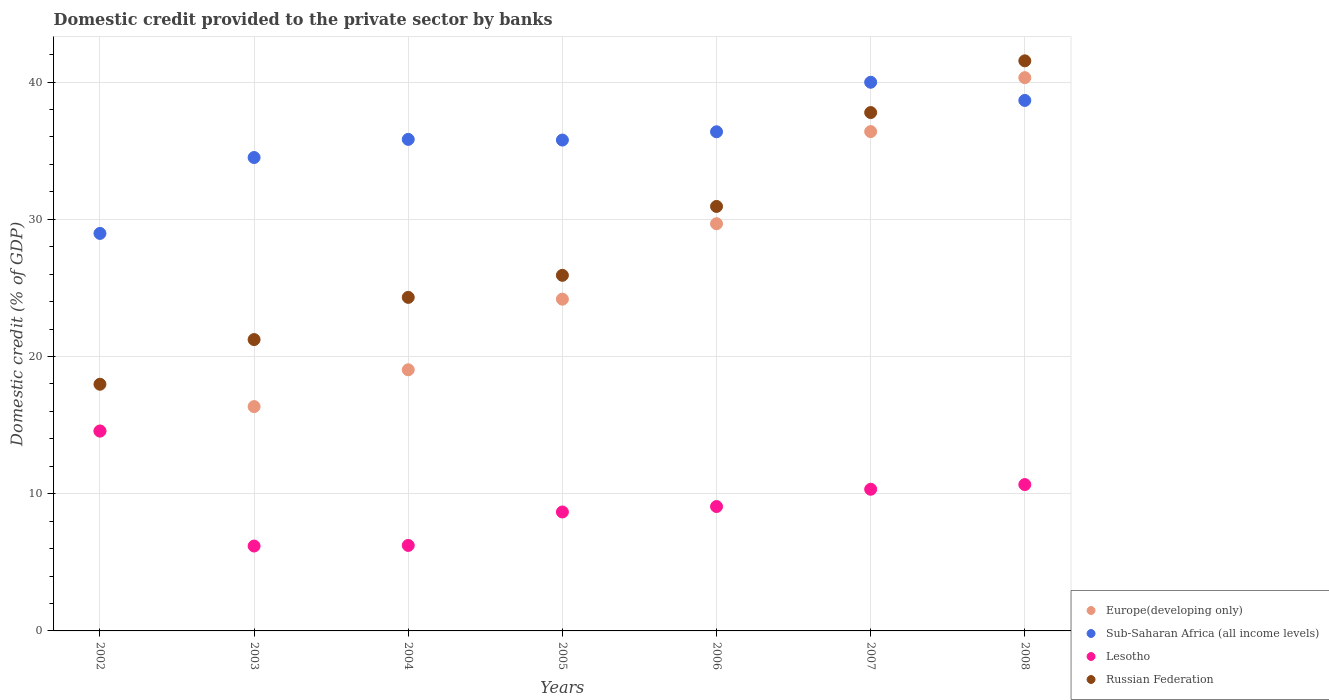Is the number of dotlines equal to the number of legend labels?
Offer a very short reply. Yes. What is the domestic credit provided to the private sector by banks in Sub-Saharan Africa (all income levels) in 2006?
Your response must be concise. 36.38. Across all years, what is the maximum domestic credit provided to the private sector by banks in Russian Federation?
Give a very brief answer. 41.55. Across all years, what is the minimum domestic credit provided to the private sector by banks in Sub-Saharan Africa (all income levels)?
Provide a short and direct response. 28.97. In which year was the domestic credit provided to the private sector by banks in Russian Federation minimum?
Offer a very short reply. 2002. What is the total domestic credit provided to the private sector by banks in Europe(developing only) in the graph?
Keep it short and to the point. 180.53. What is the difference between the domestic credit provided to the private sector by banks in Lesotho in 2002 and that in 2003?
Your answer should be compact. 8.38. What is the difference between the domestic credit provided to the private sector by banks in Russian Federation in 2005 and the domestic credit provided to the private sector by banks in Sub-Saharan Africa (all income levels) in 2007?
Provide a short and direct response. -14.07. What is the average domestic credit provided to the private sector by banks in Russian Federation per year?
Ensure brevity in your answer.  28.53. In the year 2004, what is the difference between the domestic credit provided to the private sector by banks in Lesotho and domestic credit provided to the private sector by banks in Russian Federation?
Your answer should be compact. -18.08. What is the ratio of the domestic credit provided to the private sector by banks in Russian Federation in 2003 to that in 2008?
Make the answer very short. 0.51. Is the domestic credit provided to the private sector by banks in Sub-Saharan Africa (all income levels) in 2003 less than that in 2007?
Make the answer very short. Yes. Is the difference between the domestic credit provided to the private sector by banks in Lesotho in 2002 and 2003 greater than the difference between the domestic credit provided to the private sector by banks in Russian Federation in 2002 and 2003?
Offer a terse response. Yes. What is the difference between the highest and the second highest domestic credit provided to the private sector by banks in Europe(developing only)?
Give a very brief answer. 3.93. What is the difference between the highest and the lowest domestic credit provided to the private sector by banks in Lesotho?
Ensure brevity in your answer.  8.38. Is the sum of the domestic credit provided to the private sector by banks in Europe(developing only) in 2005 and 2007 greater than the maximum domestic credit provided to the private sector by banks in Lesotho across all years?
Offer a terse response. Yes. Is it the case that in every year, the sum of the domestic credit provided to the private sector by banks in Lesotho and domestic credit provided to the private sector by banks in Europe(developing only)  is greater than the domestic credit provided to the private sector by banks in Sub-Saharan Africa (all income levels)?
Provide a short and direct response. No. Is the domestic credit provided to the private sector by banks in Russian Federation strictly less than the domestic credit provided to the private sector by banks in Lesotho over the years?
Your answer should be compact. No. Are the values on the major ticks of Y-axis written in scientific E-notation?
Make the answer very short. No. Does the graph contain grids?
Ensure brevity in your answer.  Yes. Where does the legend appear in the graph?
Offer a terse response. Bottom right. How are the legend labels stacked?
Offer a very short reply. Vertical. What is the title of the graph?
Give a very brief answer. Domestic credit provided to the private sector by banks. What is the label or title of the Y-axis?
Provide a short and direct response. Domestic credit (% of GDP). What is the Domestic credit (% of GDP) in Europe(developing only) in 2002?
Provide a short and direct response. 14.57. What is the Domestic credit (% of GDP) of Sub-Saharan Africa (all income levels) in 2002?
Keep it short and to the point. 28.97. What is the Domestic credit (% of GDP) in Lesotho in 2002?
Your answer should be compact. 14.57. What is the Domestic credit (% of GDP) in Russian Federation in 2002?
Provide a short and direct response. 17.98. What is the Domestic credit (% of GDP) in Europe(developing only) in 2003?
Your response must be concise. 16.35. What is the Domestic credit (% of GDP) in Sub-Saharan Africa (all income levels) in 2003?
Your response must be concise. 34.5. What is the Domestic credit (% of GDP) in Lesotho in 2003?
Provide a short and direct response. 6.19. What is the Domestic credit (% of GDP) of Russian Federation in 2003?
Make the answer very short. 21.24. What is the Domestic credit (% of GDP) in Europe(developing only) in 2004?
Keep it short and to the point. 19.03. What is the Domestic credit (% of GDP) of Sub-Saharan Africa (all income levels) in 2004?
Your response must be concise. 35.83. What is the Domestic credit (% of GDP) of Lesotho in 2004?
Ensure brevity in your answer.  6.23. What is the Domestic credit (% of GDP) of Russian Federation in 2004?
Your answer should be very brief. 24.31. What is the Domestic credit (% of GDP) of Europe(developing only) in 2005?
Your response must be concise. 24.18. What is the Domestic credit (% of GDP) of Sub-Saharan Africa (all income levels) in 2005?
Offer a very short reply. 35.78. What is the Domestic credit (% of GDP) of Lesotho in 2005?
Keep it short and to the point. 8.67. What is the Domestic credit (% of GDP) in Russian Federation in 2005?
Offer a terse response. 25.92. What is the Domestic credit (% of GDP) in Europe(developing only) in 2006?
Make the answer very short. 29.68. What is the Domestic credit (% of GDP) of Sub-Saharan Africa (all income levels) in 2006?
Your response must be concise. 36.38. What is the Domestic credit (% of GDP) of Lesotho in 2006?
Your response must be concise. 9.07. What is the Domestic credit (% of GDP) of Russian Federation in 2006?
Make the answer very short. 30.94. What is the Domestic credit (% of GDP) of Europe(developing only) in 2007?
Provide a succinct answer. 36.39. What is the Domestic credit (% of GDP) of Sub-Saharan Africa (all income levels) in 2007?
Provide a succinct answer. 39.99. What is the Domestic credit (% of GDP) of Lesotho in 2007?
Give a very brief answer. 10.32. What is the Domestic credit (% of GDP) in Russian Federation in 2007?
Ensure brevity in your answer.  37.78. What is the Domestic credit (% of GDP) of Europe(developing only) in 2008?
Your response must be concise. 40.32. What is the Domestic credit (% of GDP) of Sub-Saharan Africa (all income levels) in 2008?
Provide a succinct answer. 38.66. What is the Domestic credit (% of GDP) of Lesotho in 2008?
Make the answer very short. 10.67. What is the Domestic credit (% of GDP) in Russian Federation in 2008?
Give a very brief answer. 41.55. Across all years, what is the maximum Domestic credit (% of GDP) of Europe(developing only)?
Keep it short and to the point. 40.32. Across all years, what is the maximum Domestic credit (% of GDP) in Sub-Saharan Africa (all income levels)?
Make the answer very short. 39.99. Across all years, what is the maximum Domestic credit (% of GDP) in Lesotho?
Ensure brevity in your answer.  14.57. Across all years, what is the maximum Domestic credit (% of GDP) of Russian Federation?
Your response must be concise. 41.55. Across all years, what is the minimum Domestic credit (% of GDP) of Europe(developing only)?
Keep it short and to the point. 14.57. Across all years, what is the minimum Domestic credit (% of GDP) in Sub-Saharan Africa (all income levels)?
Your answer should be very brief. 28.97. Across all years, what is the minimum Domestic credit (% of GDP) in Lesotho?
Provide a succinct answer. 6.19. Across all years, what is the minimum Domestic credit (% of GDP) in Russian Federation?
Offer a terse response. 17.98. What is the total Domestic credit (% of GDP) in Europe(developing only) in the graph?
Ensure brevity in your answer.  180.53. What is the total Domestic credit (% of GDP) in Sub-Saharan Africa (all income levels) in the graph?
Provide a succinct answer. 250.11. What is the total Domestic credit (% of GDP) in Lesotho in the graph?
Keep it short and to the point. 65.71. What is the total Domestic credit (% of GDP) in Russian Federation in the graph?
Provide a succinct answer. 199.72. What is the difference between the Domestic credit (% of GDP) in Europe(developing only) in 2002 and that in 2003?
Your response must be concise. -1.78. What is the difference between the Domestic credit (% of GDP) in Sub-Saharan Africa (all income levels) in 2002 and that in 2003?
Provide a short and direct response. -5.53. What is the difference between the Domestic credit (% of GDP) of Lesotho in 2002 and that in 2003?
Keep it short and to the point. 8.38. What is the difference between the Domestic credit (% of GDP) in Russian Federation in 2002 and that in 2003?
Provide a short and direct response. -3.26. What is the difference between the Domestic credit (% of GDP) of Europe(developing only) in 2002 and that in 2004?
Your answer should be compact. -4.46. What is the difference between the Domestic credit (% of GDP) of Sub-Saharan Africa (all income levels) in 2002 and that in 2004?
Ensure brevity in your answer.  -6.85. What is the difference between the Domestic credit (% of GDP) of Lesotho in 2002 and that in 2004?
Offer a very short reply. 8.34. What is the difference between the Domestic credit (% of GDP) of Russian Federation in 2002 and that in 2004?
Your answer should be compact. -6.33. What is the difference between the Domestic credit (% of GDP) in Europe(developing only) in 2002 and that in 2005?
Make the answer very short. -9.61. What is the difference between the Domestic credit (% of GDP) in Sub-Saharan Africa (all income levels) in 2002 and that in 2005?
Offer a terse response. -6.8. What is the difference between the Domestic credit (% of GDP) of Lesotho in 2002 and that in 2005?
Keep it short and to the point. 5.9. What is the difference between the Domestic credit (% of GDP) in Russian Federation in 2002 and that in 2005?
Give a very brief answer. -7.94. What is the difference between the Domestic credit (% of GDP) in Europe(developing only) in 2002 and that in 2006?
Your answer should be very brief. -15.11. What is the difference between the Domestic credit (% of GDP) of Sub-Saharan Africa (all income levels) in 2002 and that in 2006?
Offer a very short reply. -7.41. What is the difference between the Domestic credit (% of GDP) in Lesotho in 2002 and that in 2006?
Keep it short and to the point. 5.5. What is the difference between the Domestic credit (% of GDP) of Russian Federation in 2002 and that in 2006?
Provide a short and direct response. -12.96. What is the difference between the Domestic credit (% of GDP) in Europe(developing only) in 2002 and that in 2007?
Your response must be concise. -21.82. What is the difference between the Domestic credit (% of GDP) of Sub-Saharan Africa (all income levels) in 2002 and that in 2007?
Keep it short and to the point. -11.02. What is the difference between the Domestic credit (% of GDP) of Lesotho in 2002 and that in 2007?
Ensure brevity in your answer.  4.24. What is the difference between the Domestic credit (% of GDP) of Russian Federation in 2002 and that in 2007?
Give a very brief answer. -19.8. What is the difference between the Domestic credit (% of GDP) of Europe(developing only) in 2002 and that in 2008?
Your response must be concise. -25.75. What is the difference between the Domestic credit (% of GDP) of Sub-Saharan Africa (all income levels) in 2002 and that in 2008?
Offer a very short reply. -9.69. What is the difference between the Domestic credit (% of GDP) in Lesotho in 2002 and that in 2008?
Make the answer very short. 3.9. What is the difference between the Domestic credit (% of GDP) in Russian Federation in 2002 and that in 2008?
Make the answer very short. -23.57. What is the difference between the Domestic credit (% of GDP) of Europe(developing only) in 2003 and that in 2004?
Make the answer very short. -2.68. What is the difference between the Domestic credit (% of GDP) of Sub-Saharan Africa (all income levels) in 2003 and that in 2004?
Ensure brevity in your answer.  -1.32. What is the difference between the Domestic credit (% of GDP) of Lesotho in 2003 and that in 2004?
Offer a terse response. -0.04. What is the difference between the Domestic credit (% of GDP) in Russian Federation in 2003 and that in 2004?
Provide a short and direct response. -3.08. What is the difference between the Domestic credit (% of GDP) in Europe(developing only) in 2003 and that in 2005?
Your answer should be compact. -7.83. What is the difference between the Domestic credit (% of GDP) in Sub-Saharan Africa (all income levels) in 2003 and that in 2005?
Make the answer very short. -1.27. What is the difference between the Domestic credit (% of GDP) of Lesotho in 2003 and that in 2005?
Keep it short and to the point. -2.48. What is the difference between the Domestic credit (% of GDP) of Russian Federation in 2003 and that in 2005?
Ensure brevity in your answer.  -4.68. What is the difference between the Domestic credit (% of GDP) of Europe(developing only) in 2003 and that in 2006?
Your response must be concise. -13.33. What is the difference between the Domestic credit (% of GDP) in Sub-Saharan Africa (all income levels) in 2003 and that in 2006?
Offer a terse response. -1.88. What is the difference between the Domestic credit (% of GDP) in Lesotho in 2003 and that in 2006?
Keep it short and to the point. -2.88. What is the difference between the Domestic credit (% of GDP) in Russian Federation in 2003 and that in 2006?
Provide a succinct answer. -9.7. What is the difference between the Domestic credit (% of GDP) in Europe(developing only) in 2003 and that in 2007?
Your answer should be compact. -20.04. What is the difference between the Domestic credit (% of GDP) of Sub-Saharan Africa (all income levels) in 2003 and that in 2007?
Your answer should be very brief. -5.49. What is the difference between the Domestic credit (% of GDP) in Lesotho in 2003 and that in 2007?
Make the answer very short. -4.14. What is the difference between the Domestic credit (% of GDP) in Russian Federation in 2003 and that in 2007?
Offer a very short reply. -16.55. What is the difference between the Domestic credit (% of GDP) of Europe(developing only) in 2003 and that in 2008?
Make the answer very short. -23.97. What is the difference between the Domestic credit (% of GDP) in Sub-Saharan Africa (all income levels) in 2003 and that in 2008?
Make the answer very short. -4.16. What is the difference between the Domestic credit (% of GDP) in Lesotho in 2003 and that in 2008?
Ensure brevity in your answer.  -4.48. What is the difference between the Domestic credit (% of GDP) of Russian Federation in 2003 and that in 2008?
Provide a succinct answer. -20.32. What is the difference between the Domestic credit (% of GDP) of Europe(developing only) in 2004 and that in 2005?
Make the answer very short. -5.15. What is the difference between the Domestic credit (% of GDP) of Sub-Saharan Africa (all income levels) in 2004 and that in 2005?
Provide a short and direct response. 0.05. What is the difference between the Domestic credit (% of GDP) of Lesotho in 2004 and that in 2005?
Your answer should be compact. -2.44. What is the difference between the Domestic credit (% of GDP) of Russian Federation in 2004 and that in 2005?
Make the answer very short. -1.61. What is the difference between the Domestic credit (% of GDP) of Europe(developing only) in 2004 and that in 2006?
Keep it short and to the point. -10.64. What is the difference between the Domestic credit (% of GDP) of Sub-Saharan Africa (all income levels) in 2004 and that in 2006?
Make the answer very short. -0.55. What is the difference between the Domestic credit (% of GDP) of Lesotho in 2004 and that in 2006?
Provide a short and direct response. -2.83. What is the difference between the Domestic credit (% of GDP) in Russian Federation in 2004 and that in 2006?
Keep it short and to the point. -6.63. What is the difference between the Domestic credit (% of GDP) in Europe(developing only) in 2004 and that in 2007?
Give a very brief answer. -17.36. What is the difference between the Domestic credit (% of GDP) in Sub-Saharan Africa (all income levels) in 2004 and that in 2007?
Offer a very short reply. -4.16. What is the difference between the Domestic credit (% of GDP) in Lesotho in 2004 and that in 2007?
Ensure brevity in your answer.  -4.09. What is the difference between the Domestic credit (% of GDP) in Russian Federation in 2004 and that in 2007?
Keep it short and to the point. -13.47. What is the difference between the Domestic credit (% of GDP) in Europe(developing only) in 2004 and that in 2008?
Your response must be concise. -21.29. What is the difference between the Domestic credit (% of GDP) of Sub-Saharan Africa (all income levels) in 2004 and that in 2008?
Keep it short and to the point. -2.84. What is the difference between the Domestic credit (% of GDP) in Lesotho in 2004 and that in 2008?
Your answer should be compact. -4.44. What is the difference between the Domestic credit (% of GDP) of Russian Federation in 2004 and that in 2008?
Provide a succinct answer. -17.24. What is the difference between the Domestic credit (% of GDP) in Europe(developing only) in 2005 and that in 2006?
Your response must be concise. -5.5. What is the difference between the Domestic credit (% of GDP) of Sub-Saharan Africa (all income levels) in 2005 and that in 2006?
Offer a terse response. -0.6. What is the difference between the Domestic credit (% of GDP) of Lesotho in 2005 and that in 2006?
Keep it short and to the point. -0.4. What is the difference between the Domestic credit (% of GDP) of Russian Federation in 2005 and that in 2006?
Your answer should be compact. -5.02. What is the difference between the Domestic credit (% of GDP) of Europe(developing only) in 2005 and that in 2007?
Provide a succinct answer. -12.21. What is the difference between the Domestic credit (% of GDP) of Sub-Saharan Africa (all income levels) in 2005 and that in 2007?
Give a very brief answer. -4.21. What is the difference between the Domestic credit (% of GDP) in Lesotho in 2005 and that in 2007?
Your response must be concise. -1.66. What is the difference between the Domestic credit (% of GDP) in Russian Federation in 2005 and that in 2007?
Ensure brevity in your answer.  -11.86. What is the difference between the Domestic credit (% of GDP) in Europe(developing only) in 2005 and that in 2008?
Your answer should be compact. -16.15. What is the difference between the Domestic credit (% of GDP) of Sub-Saharan Africa (all income levels) in 2005 and that in 2008?
Your response must be concise. -2.89. What is the difference between the Domestic credit (% of GDP) in Lesotho in 2005 and that in 2008?
Keep it short and to the point. -2. What is the difference between the Domestic credit (% of GDP) in Russian Federation in 2005 and that in 2008?
Give a very brief answer. -15.63. What is the difference between the Domestic credit (% of GDP) of Europe(developing only) in 2006 and that in 2007?
Your response must be concise. -6.72. What is the difference between the Domestic credit (% of GDP) of Sub-Saharan Africa (all income levels) in 2006 and that in 2007?
Keep it short and to the point. -3.61. What is the difference between the Domestic credit (% of GDP) in Lesotho in 2006 and that in 2007?
Give a very brief answer. -1.26. What is the difference between the Domestic credit (% of GDP) of Russian Federation in 2006 and that in 2007?
Provide a succinct answer. -6.84. What is the difference between the Domestic credit (% of GDP) in Europe(developing only) in 2006 and that in 2008?
Provide a succinct answer. -10.65. What is the difference between the Domestic credit (% of GDP) of Sub-Saharan Africa (all income levels) in 2006 and that in 2008?
Give a very brief answer. -2.28. What is the difference between the Domestic credit (% of GDP) in Lesotho in 2006 and that in 2008?
Offer a terse response. -1.6. What is the difference between the Domestic credit (% of GDP) of Russian Federation in 2006 and that in 2008?
Your response must be concise. -10.61. What is the difference between the Domestic credit (% of GDP) in Europe(developing only) in 2007 and that in 2008?
Make the answer very short. -3.93. What is the difference between the Domestic credit (% of GDP) in Sub-Saharan Africa (all income levels) in 2007 and that in 2008?
Give a very brief answer. 1.32. What is the difference between the Domestic credit (% of GDP) of Lesotho in 2007 and that in 2008?
Provide a succinct answer. -0.34. What is the difference between the Domestic credit (% of GDP) in Russian Federation in 2007 and that in 2008?
Give a very brief answer. -3.77. What is the difference between the Domestic credit (% of GDP) of Europe(developing only) in 2002 and the Domestic credit (% of GDP) of Sub-Saharan Africa (all income levels) in 2003?
Give a very brief answer. -19.93. What is the difference between the Domestic credit (% of GDP) of Europe(developing only) in 2002 and the Domestic credit (% of GDP) of Lesotho in 2003?
Offer a very short reply. 8.38. What is the difference between the Domestic credit (% of GDP) of Europe(developing only) in 2002 and the Domestic credit (% of GDP) of Russian Federation in 2003?
Your answer should be very brief. -6.66. What is the difference between the Domestic credit (% of GDP) of Sub-Saharan Africa (all income levels) in 2002 and the Domestic credit (% of GDP) of Lesotho in 2003?
Your answer should be compact. 22.79. What is the difference between the Domestic credit (% of GDP) in Sub-Saharan Africa (all income levels) in 2002 and the Domestic credit (% of GDP) in Russian Federation in 2003?
Offer a terse response. 7.74. What is the difference between the Domestic credit (% of GDP) of Lesotho in 2002 and the Domestic credit (% of GDP) of Russian Federation in 2003?
Your answer should be compact. -6.67. What is the difference between the Domestic credit (% of GDP) in Europe(developing only) in 2002 and the Domestic credit (% of GDP) in Sub-Saharan Africa (all income levels) in 2004?
Your response must be concise. -21.25. What is the difference between the Domestic credit (% of GDP) in Europe(developing only) in 2002 and the Domestic credit (% of GDP) in Lesotho in 2004?
Keep it short and to the point. 8.34. What is the difference between the Domestic credit (% of GDP) of Europe(developing only) in 2002 and the Domestic credit (% of GDP) of Russian Federation in 2004?
Provide a succinct answer. -9.74. What is the difference between the Domestic credit (% of GDP) of Sub-Saharan Africa (all income levels) in 2002 and the Domestic credit (% of GDP) of Lesotho in 2004?
Ensure brevity in your answer.  22.74. What is the difference between the Domestic credit (% of GDP) of Sub-Saharan Africa (all income levels) in 2002 and the Domestic credit (% of GDP) of Russian Federation in 2004?
Make the answer very short. 4.66. What is the difference between the Domestic credit (% of GDP) in Lesotho in 2002 and the Domestic credit (% of GDP) in Russian Federation in 2004?
Give a very brief answer. -9.74. What is the difference between the Domestic credit (% of GDP) of Europe(developing only) in 2002 and the Domestic credit (% of GDP) of Sub-Saharan Africa (all income levels) in 2005?
Give a very brief answer. -21.21. What is the difference between the Domestic credit (% of GDP) in Europe(developing only) in 2002 and the Domestic credit (% of GDP) in Lesotho in 2005?
Keep it short and to the point. 5.9. What is the difference between the Domestic credit (% of GDP) in Europe(developing only) in 2002 and the Domestic credit (% of GDP) in Russian Federation in 2005?
Make the answer very short. -11.35. What is the difference between the Domestic credit (% of GDP) in Sub-Saharan Africa (all income levels) in 2002 and the Domestic credit (% of GDP) in Lesotho in 2005?
Your answer should be compact. 20.3. What is the difference between the Domestic credit (% of GDP) of Sub-Saharan Africa (all income levels) in 2002 and the Domestic credit (% of GDP) of Russian Federation in 2005?
Ensure brevity in your answer.  3.05. What is the difference between the Domestic credit (% of GDP) of Lesotho in 2002 and the Domestic credit (% of GDP) of Russian Federation in 2005?
Your response must be concise. -11.35. What is the difference between the Domestic credit (% of GDP) of Europe(developing only) in 2002 and the Domestic credit (% of GDP) of Sub-Saharan Africa (all income levels) in 2006?
Provide a short and direct response. -21.81. What is the difference between the Domestic credit (% of GDP) of Europe(developing only) in 2002 and the Domestic credit (% of GDP) of Lesotho in 2006?
Your response must be concise. 5.51. What is the difference between the Domestic credit (% of GDP) in Europe(developing only) in 2002 and the Domestic credit (% of GDP) in Russian Federation in 2006?
Offer a very short reply. -16.37. What is the difference between the Domestic credit (% of GDP) in Sub-Saharan Africa (all income levels) in 2002 and the Domestic credit (% of GDP) in Lesotho in 2006?
Offer a very short reply. 19.91. What is the difference between the Domestic credit (% of GDP) of Sub-Saharan Africa (all income levels) in 2002 and the Domestic credit (% of GDP) of Russian Federation in 2006?
Give a very brief answer. -1.97. What is the difference between the Domestic credit (% of GDP) in Lesotho in 2002 and the Domestic credit (% of GDP) in Russian Federation in 2006?
Ensure brevity in your answer.  -16.37. What is the difference between the Domestic credit (% of GDP) in Europe(developing only) in 2002 and the Domestic credit (% of GDP) in Sub-Saharan Africa (all income levels) in 2007?
Offer a terse response. -25.42. What is the difference between the Domestic credit (% of GDP) of Europe(developing only) in 2002 and the Domestic credit (% of GDP) of Lesotho in 2007?
Offer a very short reply. 4.25. What is the difference between the Domestic credit (% of GDP) of Europe(developing only) in 2002 and the Domestic credit (% of GDP) of Russian Federation in 2007?
Offer a terse response. -23.21. What is the difference between the Domestic credit (% of GDP) of Sub-Saharan Africa (all income levels) in 2002 and the Domestic credit (% of GDP) of Lesotho in 2007?
Ensure brevity in your answer.  18.65. What is the difference between the Domestic credit (% of GDP) of Sub-Saharan Africa (all income levels) in 2002 and the Domestic credit (% of GDP) of Russian Federation in 2007?
Ensure brevity in your answer.  -8.81. What is the difference between the Domestic credit (% of GDP) in Lesotho in 2002 and the Domestic credit (% of GDP) in Russian Federation in 2007?
Make the answer very short. -23.22. What is the difference between the Domestic credit (% of GDP) of Europe(developing only) in 2002 and the Domestic credit (% of GDP) of Sub-Saharan Africa (all income levels) in 2008?
Ensure brevity in your answer.  -24.09. What is the difference between the Domestic credit (% of GDP) of Europe(developing only) in 2002 and the Domestic credit (% of GDP) of Lesotho in 2008?
Offer a terse response. 3.9. What is the difference between the Domestic credit (% of GDP) in Europe(developing only) in 2002 and the Domestic credit (% of GDP) in Russian Federation in 2008?
Offer a terse response. -26.98. What is the difference between the Domestic credit (% of GDP) of Sub-Saharan Africa (all income levels) in 2002 and the Domestic credit (% of GDP) of Lesotho in 2008?
Ensure brevity in your answer.  18.3. What is the difference between the Domestic credit (% of GDP) of Sub-Saharan Africa (all income levels) in 2002 and the Domestic credit (% of GDP) of Russian Federation in 2008?
Ensure brevity in your answer.  -12.58. What is the difference between the Domestic credit (% of GDP) in Lesotho in 2002 and the Domestic credit (% of GDP) in Russian Federation in 2008?
Your answer should be compact. -26.98. What is the difference between the Domestic credit (% of GDP) of Europe(developing only) in 2003 and the Domestic credit (% of GDP) of Sub-Saharan Africa (all income levels) in 2004?
Keep it short and to the point. -19.48. What is the difference between the Domestic credit (% of GDP) of Europe(developing only) in 2003 and the Domestic credit (% of GDP) of Lesotho in 2004?
Offer a very short reply. 10.12. What is the difference between the Domestic credit (% of GDP) of Europe(developing only) in 2003 and the Domestic credit (% of GDP) of Russian Federation in 2004?
Make the answer very short. -7.96. What is the difference between the Domestic credit (% of GDP) of Sub-Saharan Africa (all income levels) in 2003 and the Domestic credit (% of GDP) of Lesotho in 2004?
Ensure brevity in your answer.  28.27. What is the difference between the Domestic credit (% of GDP) in Sub-Saharan Africa (all income levels) in 2003 and the Domestic credit (% of GDP) in Russian Federation in 2004?
Keep it short and to the point. 10.19. What is the difference between the Domestic credit (% of GDP) of Lesotho in 2003 and the Domestic credit (% of GDP) of Russian Federation in 2004?
Provide a succinct answer. -18.12. What is the difference between the Domestic credit (% of GDP) in Europe(developing only) in 2003 and the Domestic credit (% of GDP) in Sub-Saharan Africa (all income levels) in 2005?
Keep it short and to the point. -19.43. What is the difference between the Domestic credit (% of GDP) in Europe(developing only) in 2003 and the Domestic credit (% of GDP) in Lesotho in 2005?
Ensure brevity in your answer.  7.68. What is the difference between the Domestic credit (% of GDP) in Europe(developing only) in 2003 and the Domestic credit (% of GDP) in Russian Federation in 2005?
Your answer should be very brief. -9.57. What is the difference between the Domestic credit (% of GDP) of Sub-Saharan Africa (all income levels) in 2003 and the Domestic credit (% of GDP) of Lesotho in 2005?
Offer a terse response. 25.84. What is the difference between the Domestic credit (% of GDP) in Sub-Saharan Africa (all income levels) in 2003 and the Domestic credit (% of GDP) in Russian Federation in 2005?
Offer a very short reply. 8.59. What is the difference between the Domestic credit (% of GDP) of Lesotho in 2003 and the Domestic credit (% of GDP) of Russian Federation in 2005?
Your response must be concise. -19.73. What is the difference between the Domestic credit (% of GDP) in Europe(developing only) in 2003 and the Domestic credit (% of GDP) in Sub-Saharan Africa (all income levels) in 2006?
Your answer should be very brief. -20.03. What is the difference between the Domestic credit (% of GDP) of Europe(developing only) in 2003 and the Domestic credit (% of GDP) of Lesotho in 2006?
Make the answer very short. 7.29. What is the difference between the Domestic credit (% of GDP) of Europe(developing only) in 2003 and the Domestic credit (% of GDP) of Russian Federation in 2006?
Ensure brevity in your answer.  -14.59. What is the difference between the Domestic credit (% of GDP) of Sub-Saharan Africa (all income levels) in 2003 and the Domestic credit (% of GDP) of Lesotho in 2006?
Give a very brief answer. 25.44. What is the difference between the Domestic credit (% of GDP) in Sub-Saharan Africa (all income levels) in 2003 and the Domestic credit (% of GDP) in Russian Federation in 2006?
Make the answer very short. 3.57. What is the difference between the Domestic credit (% of GDP) in Lesotho in 2003 and the Domestic credit (% of GDP) in Russian Federation in 2006?
Offer a terse response. -24.75. What is the difference between the Domestic credit (% of GDP) of Europe(developing only) in 2003 and the Domestic credit (% of GDP) of Sub-Saharan Africa (all income levels) in 2007?
Your response must be concise. -23.64. What is the difference between the Domestic credit (% of GDP) in Europe(developing only) in 2003 and the Domestic credit (% of GDP) in Lesotho in 2007?
Your response must be concise. 6.03. What is the difference between the Domestic credit (% of GDP) in Europe(developing only) in 2003 and the Domestic credit (% of GDP) in Russian Federation in 2007?
Give a very brief answer. -21.43. What is the difference between the Domestic credit (% of GDP) in Sub-Saharan Africa (all income levels) in 2003 and the Domestic credit (% of GDP) in Lesotho in 2007?
Provide a short and direct response. 24.18. What is the difference between the Domestic credit (% of GDP) in Sub-Saharan Africa (all income levels) in 2003 and the Domestic credit (% of GDP) in Russian Federation in 2007?
Provide a succinct answer. -3.28. What is the difference between the Domestic credit (% of GDP) in Lesotho in 2003 and the Domestic credit (% of GDP) in Russian Federation in 2007?
Offer a terse response. -31.59. What is the difference between the Domestic credit (% of GDP) in Europe(developing only) in 2003 and the Domestic credit (% of GDP) in Sub-Saharan Africa (all income levels) in 2008?
Your response must be concise. -22.31. What is the difference between the Domestic credit (% of GDP) of Europe(developing only) in 2003 and the Domestic credit (% of GDP) of Lesotho in 2008?
Your answer should be very brief. 5.68. What is the difference between the Domestic credit (% of GDP) in Europe(developing only) in 2003 and the Domestic credit (% of GDP) in Russian Federation in 2008?
Offer a very short reply. -25.2. What is the difference between the Domestic credit (% of GDP) in Sub-Saharan Africa (all income levels) in 2003 and the Domestic credit (% of GDP) in Lesotho in 2008?
Make the answer very short. 23.84. What is the difference between the Domestic credit (% of GDP) of Sub-Saharan Africa (all income levels) in 2003 and the Domestic credit (% of GDP) of Russian Federation in 2008?
Provide a succinct answer. -7.05. What is the difference between the Domestic credit (% of GDP) of Lesotho in 2003 and the Domestic credit (% of GDP) of Russian Federation in 2008?
Give a very brief answer. -35.36. What is the difference between the Domestic credit (% of GDP) of Europe(developing only) in 2004 and the Domestic credit (% of GDP) of Sub-Saharan Africa (all income levels) in 2005?
Provide a short and direct response. -16.74. What is the difference between the Domestic credit (% of GDP) in Europe(developing only) in 2004 and the Domestic credit (% of GDP) in Lesotho in 2005?
Give a very brief answer. 10.36. What is the difference between the Domestic credit (% of GDP) in Europe(developing only) in 2004 and the Domestic credit (% of GDP) in Russian Federation in 2005?
Offer a very short reply. -6.89. What is the difference between the Domestic credit (% of GDP) in Sub-Saharan Africa (all income levels) in 2004 and the Domestic credit (% of GDP) in Lesotho in 2005?
Offer a very short reply. 27.16. What is the difference between the Domestic credit (% of GDP) in Sub-Saharan Africa (all income levels) in 2004 and the Domestic credit (% of GDP) in Russian Federation in 2005?
Ensure brevity in your answer.  9.91. What is the difference between the Domestic credit (% of GDP) of Lesotho in 2004 and the Domestic credit (% of GDP) of Russian Federation in 2005?
Make the answer very short. -19.69. What is the difference between the Domestic credit (% of GDP) of Europe(developing only) in 2004 and the Domestic credit (% of GDP) of Sub-Saharan Africa (all income levels) in 2006?
Ensure brevity in your answer.  -17.35. What is the difference between the Domestic credit (% of GDP) of Europe(developing only) in 2004 and the Domestic credit (% of GDP) of Lesotho in 2006?
Offer a terse response. 9.97. What is the difference between the Domestic credit (% of GDP) of Europe(developing only) in 2004 and the Domestic credit (% of GDP) of Russian Federation in 2006?
Make the answer very short. -11.91. What is the difference between the Domestic credit (% of GDP) in Sub-Saharan Africa (all income levels) in 2004 and the Domestic credit (% of GDP) in Lesotho in 2006?
Give a very brief answer. 26.76. What is the difference between the Domestic credit (% of GDP) of Sub-Saharan Africa (all income levels) in 2004 and the Domestic credit (% of GDP) of Russian Federation in 2006?
Provide a short and direct response. 4.89. What is the difference between the Domestic credit (% of GDP) in Lesotho in 2004 and the Domestic credit (% of GDP) in Russian Federation in 2006?
Your answer should be very brief. -24.71. What is the difference between the Domestic credit (% of GDP) of Europe(developing only) in 2004 and the Domestic credit (% of GDP) of Sub-Saharan Africa (all income levels) in 2007?
Offer a very short reply. -20.96. What is the difference between the Domestic credit (% of GDP) in Europe(developing only) in 2004 and the Domestic credit (% of GDP) in Lesotho in 2007?
Your response must be concise. 8.71. What is the difference between the Domestic credit (% of GDP) of Europe(developing only) in 2004 and the Domestic credit (% of GDP) of Russian Federation in 2007?
Keep it short and to the point. -18.75. What is the difference between the Domestic credit (% of GDP) of Sub-Saharan Africa (all income levels) in 2004 and the Domestic credit (% of GDP) of Lesotho in 2007?
Make the answer very short. 25.5. What is the difference between the Domestic credit (% of GDP) in Sub-Saharan Africa (all income levels) in 2004 and the Domestic credit (% of GDP) in Russian Federation in 2007?
Provide a short and direct response. -1.96. What is the difference between the Domestic credit (% of GDP) of Lesotho in 2004 and the Domestic credit (% of GDP) of Russian Federation in 2007?
Provide a succinct answer. -31.55. What is the difference between the Domestic credit (% of GDP) in Europe(developing only) in 2004 and the Domestic credit (% of GDP) in Sub-Saharan Africa (all income levels) in 2008?
Make the answer very short. -19.63. What is the difference between the Domestic credit (% of GDP) in Europe(developing only) in 2004 and the Domestic credit (% of GDP) in Lesotho in 2008?
Ensure brevity in your answer.  8.37. What is the difference between the Domestic credit (% of GDP) in Europe(developing only) in 2004 and the Domestic credit (% of GDP) in Russian Federation in 2008?
Keep it short and to the point. -22.52. What is the difference between the Domestic credit (% of GDP) of Sub-Saharan Africa (all income levels) in 2004 and the Domestic credit (% of GDP) of Lesotho in 2008?
Your response must be concise. 25.16. What is the difference between the Domestic credit (% of GDP) of Sub-Saharan Africa (all income levels) in 2004 and the Domestic credit (% of GDP) of Russian Federation in 2008?
Ensure brevity in your answer.  -5.72. What is the difference between the Domestic credit (% of GDP) of Lesotho in 2004 and the Domestic credit (% of GDP) of Russian Federation in 2008?
Keep it short and to the point. -35.32. What is the difference between the Domestic credit (% of GDP) in Europe(developing only) in 2005 and the Domestic credit (% of GDP) in Sub-Saharan Africa (all income levels) in 2006?
Make the answer very short. -12.2. What is the difference between the Domestic credit (% of GDP) in Europe(developing only) in 2005 and the Domestic credit (% of GDP) in Lesotho in 2006?
Ensure brevity in your answer.  15.11. What is the difference between the Domestic credit (% of GDP) of Europe(developing only) in 2005 and the Domestic credit (% of GDP) of Russian Federation in 2006?
Provide a succinct answer. -6.76. What is the difference between the Domestic credit (% of GDP) of Sub-Saharan Africa (all income levels) in 2005 and the Domestic credit (% of GDP) of Lesotho in 2006?
Provide a succinct answer. 26.71. What is the difference between the Domestic credit (% of GDP) in Sub-Saharan Africa (all income levels) in 2005 and the Domestic credit (% of GDP) in Russian Federation in 2006?
Provide a succinct answer. 4.84. What is the difference between the Domestic credit (% of GDP) in Lesotho in 2005 and the Domestic credit (% of GDP) in Russian Federation in 2006?
Make the answer very short. -22.27. What is the difference between the Domestic credit (% of GDP) of Europe(developing only) in 2005 and the Domestic credit (% of GDP) of Sub-Saharan Africa (all income levels) in 2007?
Your response must be concise. -15.81. What is the difference between the Domestic credit (% of GDP) of Europe(developing only) in 2005 and the Domestic credit (% of GDP) of Lesotho in 2007?
Give a very brief answer. 13.85. What is the difference between the Domestic credit (% of GDP) of Europe(developing only) in 2005 and the Domestic credit (% of GDP) of Russian Federation in 2007?
Offer a very short reply. -13.6. What is the difference between the Domestic credit (% of GDP) of Sub-Saharan Africa (all income levels) in 2005 and the Domestic credit (% of GDP) of Lesotho in 2007?
Your answer should be very brief. 25.45. What is the difference between the Domestic credit (% of GDP) of Sub-Saharan Africa (all income levels) in 2005 and the Domestic credit (% of GDP) of Russian Federation in 2007?
Your answer should be compact. -2. What is the difference between the Domestic credit (% of GDP) in Lesotho in 2005 and the Domestic credit (% of GDP) in Russian Federation in 2007?
Ensure brevity in your answer.  -29.11. What is the difference between the Domestic credit (% of GDP) in Europe(developing only) in 2005 and the Domestic credit (% of GDP) in Sub-Saharan Africa (all income levels) in 2008?
Your answer should be very brief. -14.49. What is the difference between the Domestic credit (% of GDP) in Europe(developing only) in 2005 and the Domestic credit (% of GDP) in Lesotho in 2008?
Make the answer very short. 13.51. What is the difference between the Domestic credit (% of GDP) in Europe(developing only) in 2005 and the Domestic credit (% of GDP) in Russian Federation in 2008?
Your response must be concise. -17.37. What is the difference between the Domestic credit (% of GDP) of Sub-Saharan Africa (all income levels) in 2005 and the Domestic credit (% of GDP) of Lesotho in 2008?
Offer a very short reply. 25.11. What is the difference between the Domestic credit (% of GDP) in Sub-Saharan Africa (all income levels) in 2005 and the Domestic credit (% of GDP) in Russian Federation in 2008?
Make the answer very short. -5.77. What is the difference between the Domestic credit (% of GDP) in Lesotho in 2005 and the Domestic credit (% of GDP) in Russian Federation in 2008?
Offer a terse response. -32.88. What is the difference between the Domestic credit (% of GDP) of Europe(developing only) in 2006 and the Domestic credit (% of GDP) of Sub-Saharan Africa (all income levels) in 2007?
Your answer should be compact. -10.31. What is the difference between the Domestic credit (% of GDP) of Europe(developing only) in 2006 and the Domestic credit (% of GDP) of Lesotho in 2007?
Provide a short and direct response. 19.35. What is the difference between the Domestic credit (% of GDP) of Europe(developing only) in 2006 and the Domestic credit (% of GDP) of Russian Federation in 2007?
Offer a very short reply. -8.1. What is the difference between the Domestic credit (% of GDP) of Sub-Saharan Africa (all income levels) in 2006 and the Domestic credit (% of GDP) of Lesotho in 2007?
Keep it short and to the point. 26.06. What is the difference between the Domestic credit (% of GDP) in Sub-Saharan Africa (all income levels) in 2006 and the Domestic credit (% of GDP) in Russian Federation in 2007?
Ensure brevity in your answer.  -1.4. What is the difference between the Domestic credit (% of GDP) in Lesotho in 2006 and the Domestic credit (% of GDP) in Russian Federation in 2007?
Provide a succinct answer. -28.72. What is the difference between the Domestic credit (% of GDP) in Europe(developing only) in 2006 and the Domestic credit (% of GDP) in Sub-Saharan Africa (all income levels) in 2008?
Offer a terse response. -8.99. What is the difference between the Domestic credit (% of GDP) in Europe(developing only) in 2006 and the Domestic credit (% of GDP) in Lesotho in 2008?
Offer a terse response. 19.01. What is the difference between the Domestic credit (% of GDP) in Europe(developing only) in 2006 and the Domestic credit (% of GDP) in Russian Federation in 2008?
Offer a terse response. -11.87. What is the difference between the Domestic credit (% of GDP) of Sub-Saharan Africa (all income levels) in 2006 and the Domestic credit (% of GDP) of Lesotho in 2008?
Your response must be concise. 25.71. What is the difference between the Domestic credit (% of GDP) of Sub-Saharan Africa (all income levels) in 2006 and the Domestic credit (% of GDP) of Russian Federation in 2008?
Offer a very short reply. -5.17. What is the difference between the Domestic credit (% of GDP) in Lesotho in 2006 and the Domestic credit (% of GDP) in Russian Federation in 2008?
Give a very brief answer. -32.49. What is the difference between the Domestic credit (% of GDP) in Europe(developing only) in 2007 and the Domestic credit (% of GDP) in Sub-Saharan Africa (all income levels) in 2008?
Offer a terse response. -2.27. What is the difference between the Domestic credit (% of GDP) in Europe(developing only) in 2007 and the Domestic credit (% of GDP) in Lesotho in 2008?
Offer a terse response. 25.73. What is the difference between the Domestic credit (% of GDP) in Europe(developing only) in 2007 and the Domestic credit (% of GDP) in Russian Federation in 2008?
Ensure brevity in your answer.  -5.16. What is the difference between the Domestic credit (% of GDP) of Sub-Saharan Africa (all income levels) in 2007 and the Domestic credit (% of GDP) of Lesotho in 2008?
Offer a very short reply. 29.32. What is the difference between the Domestic credit (% of GDP) in Sub-Saharan Africa (all income levels) in 2007 and the Domestic credit (% of GDP) in Russian Federation in 2008?
Offer a very short reply. -1.56. What is the difference between the Domestic credit (% of GDP) in Lesotho in 2007 and the Domestic credit (% of GDP) in Russian Federation in 2008?
Your response must be concise. -31.23. What is the average Domestic credit (% of GDP) of Europe(developing only) per year?
Make the answer very short. 25.79. What is the average Domestic credit (% of GDP) of Sub-Saharan Africa (all income levels) per year?
Your answer should be compact. 35.73. What is the average Domestic credit (% of GDP) in Lesotho per year?
Provide a succinct answer. 9.39. What is the average Domestic credit (% of GDP) of Russian Federation per year?
Ensure brevity in your answer.  28.53. In the year 2002, what is the difference between the Domestic credit (% of GDP) of Europe(developing only) and Domestic credit (% of GDP) of Sub-Saharan Africa (all income levels)?
Offer a very short reply. -14.4. In the year 2002, what is the difference between the Domestic credit (% of GDP) of Europe(developing only) and Domestic credit (% of GDP) of Lesotho?
Offer a terse response. 0.01. In the year 2002, what is the difference between the Domestic credit (% of GDP) of Europe(developing only) and Domestic credit (% of GDP) of Russian Federation?
Your answer should be compact. -3.41. In the year 2002, what is the difference between the Domestic credit (% of GDP) in Sub-Saharan Africa (all income levels) and Domestic credit (% of GDP) in Lesotho?
Your response must be concise. 14.41. In the year 2002, what is the difference between the Domestic credit (% of GDP) of Sub-Saharan Africa (all income levels) and Domestic credit (% of GDP) of Russian Federation?
Make the answer very short. 10.99. In the year 2002, what is the difference between the Domestic credit (% of GDP) of Lesotho and Domestic credit (% of GDP) of Russian Federation?
Offer a terse response. -3.41. In the year 2003, what is the difference between the Domestic credit (% of GDP) of Europe(developing only) and Domestic credit (% of GDP) of Sub-Saharan Africa (all income levels)?
Provide a succinct answer. -18.15. In the year 2003, what is the difference between the Domestic credit (% of GDP) of Europe(developing only) and Domestic credit (% of GDP) of Lesotho?
Give a very brief answer. 10.16. In the year 2003, what is the difference between the Domestic credit (% of GDP) of Europe(developing only) and Domestic credit (% of GDP) of Russian Federation?
Offer a very short reply. -4.88. In the year 2003, what is the difference between the Domestic credit (% of GDP) in Sub-Saharan Africa (all income levels) and Domestic credit (% of GDP) in Lesotho?
Keep it short and to the point. 28.32. In the year 2003, what is the difference between the Domestic credit (% of GDP) of Sub-Saharan Africa (all income levels) and Domestic credit (% of GDP) of Russian Federation?
Give a very brief answer. 13.27. In the year 2003, what is the difference between the Domestic credit (% of GDP) of Lesotho and Domestic credit (% of GDP) of Russian Federation?
Keep it short and to the point. -15.05. In the year 2004, what is the difference between the Domestic credit (% of GDP) in Europe(developing only) and Domestic credit (% of GDP) in Sub-Saharan Africa (all income levels)?
Make the answer very short. -16.79. In the year 2004, what is the difference between the Domestic credit (% of GDP) in Europe(developing only) and Domestic credit (% of GDP) in Lesotho?
Offer a very short reply. 12.8. In the year 2004, what is the difference between the Domestic credit (% of GDP) of Europe(developing only) and Domestic credit (% of GDP) of Russian Federation?
Make the answer very short. -5.28. In the year 2004, what is the difference between the Domestic credit (% of GDP) of Sub-Saharan Africa (all income levels) and Domestic credit (% of GDP) of Lesotho?
Your response must be concise. 29.59. In the year 2004, what is the difference between the Domestic credit (% of GDP) of Sub-Saharan Africa (all income levels) and Domestic credit (% of GDP) of Russian Federation?
Offer a terse response. 11.51. In the year 2004, what is the difference between the Domestic credit (% of GDP) of Lesotho and Domestic credit (% of GDP) of Russian Federation?
Your answer should be compact. -18.08. In the year 2005, what is the difference between the Domestic credit (% of GDP) of Europe(developing only) and Domestic credit (% of GDP) of Sub-Saharan Africa (all income levels)?
Provide a short and direct response. -11.6. In the year 2005, what is the difference between the Domestic credit (% of GDP) in Europe(developing only) and Domestic credit (% of GDP) in Lesotho?
Ensure brevity in your answer.  15.51. In the year 2005, what is the difference between the Domestic credit (% of GDP) of Europe(developing only) and Domestic credit (% of GDP) of Russian Federation?
Provide a short and direct response. -1.74. In the year 2005, what is the difference between the Domestic credit (% of GDP) of Sub-Saharan Africa (all income levels) and Domestic credit (% of GDP) of Lesotho?
Keep it short and to the point. 27.11. In the year 2005, what is the difference between the Domestic credit (% of GDP) in Sub-Saharan Africa (all income levels) and Domestic credit (% of GDP) in Russian Federation?
Your response must be concise. 9.86. In the year 2005, what is the difference between the Domestic credit (% of GDP) of Lesotho and Domestic credit (% of GDP) of Russian Federation?
Make the answer very short. -17.25. In the year 2006, what is the difference between the Domestic credit (% of GDP) in Europe(developing only) and Domestic credit (% of GDP) in Sub-Saharan Africa (all income levels)?
Offer a terse response. -6.7. In the year 2006, what is the difference between the Domestic credit (% of GDP) of Europe(developing only) and Domestic credit (% of GDP) of Lesotho?
Keep it short and to the point. 20.61. In the year 2006, what is the difference between the Domestic credit (% of GDP) of Europe(developing only) and Domestic credit (% of GDP) of Russian Federation?
Your answer should be compact. -1.26. In the year 2006, what is the difference between the Domestic credit (% of GDP) in Sub-Saharan Africa (all income levels) and Domestic credit (% of GDP) in Lesotho?
Your answer should be compact. 27.31. In the year 2006, what is the difference between the Domestic credit (% of GDP) in Sub-Saharan Africa (all income levels) and Domestic credit (% of GDP) in Russian Federation?
Provide a succinct answer. 5.44. In the year 2006, what is the difference between the Domestic credit (% of GDP) of Lesotho and Domestic credit (% of GDP) of Russian Federation?
Your answer should be compact. -21.87. In the year 2007, what is the difference between the Domestic credit (% of GDP) in Europe(developing only) and Domestic credit (% of GDP) in Sub-Saharan Africa (all income levels)?
Provide a succinct answer. -3.6. In the year 2007, what is the difference between the Domestic credit (% of GDP) in Europe(developing only) and Domestic credit (% of GDP) in Lesotho?
Provide a succinct answer. 26.07. In the year 2007, what is the difference between the Domestic credit (% of GDP) in Europe(developing only) and Domestic credit (% of GDP) in Russian Federation?
Your response must be concise. -1.39. In the year 2007, what is the difference between the Domestic credit (% of GDP) of Sub-Saharan Africa (all income levels) and Domestic credit (% of GDP) of Lesotho?
Your answer should be very brief. 29.66. In the year 2007, what is the difference between the Domestic credit (% of GDP) of Sub-Saharan Africa (all income levels) and Domestic credit (% of GDP) of Russian Federation?
Ensure brevity in your answer.  2.21. In the year 2007, what is the difference between the Domestic credit (% of GDP) in Lesotho and Domestic credit (% of GDP) in Russian Federation?
Give a very brief answer. -27.46. In the year 2008, what is the difference between the Domestic credit (% of GDP) in Europe(developing only) and Domestic credit (% of GDP) in Sub-Saharan Africa (all income levels)?
Keep it short and to the point. 1.66. In the year 2008, what is the difference between the Domestic credit (% of GDP) in Europe(developing only) and Domestic credit (% of GDP) in Lesotho?
Your response must be concise. 29.66. In the year 2008, what is the difference between the Domestic credit (% of GDP) in Europe(developing only) and Domestic credit (% of GDP) in Russian Federation?
Your response must be concise. -1.23. In the year 2008, what is the difference between the Domestic credit (% of GDP) in Sub-Saharan Africa (all income levels) and Domestic credit (% of GDP) in Lesotho?
Your response must be concise. 28. In the year 2008, what is the difference between the Domestic credit (% of GDP) in Sub-Saharan Africa (all income levels) and Domestic credit (% of GDP) in Russian Federation?
Give a very brief answer. -2.89. In the year 2008, what is the difference between the Domestic credit (% of GDP) of Lesotho and Domestic credit (% of GDP) of Russian Federation?
Your answer should be very brief. -30.88. What is the ratio of the Domestic credit (% of GDP) in Europe(developing only) in 2002 to that in 2003?
Offer a very short reply. 0.89. What is the ratio of the Domestic credit (% of GDP) of Sub-Saharan Africa (all income levels) in 2002 to that in 2003?
Offer a terse response. 0.84. What is the ratio of the Domestic credit (% of GDP) of Lesotho in 2002 to that in 2003?
Make the answer very short. 2.35. What is the ratio of the Domestic credit (% of GDP) of Russian Federation in 2002 to that in 2003?
Keep it short and to the point. 0.85. What is the ratio of the Domestic credit (% of GDP) in Europe(developing only) in 2002 to that in 2004?
Offer a very short reply. 0.77. What is the ratio of the Domestic credit (% of GDP) of Sub-Saharan Africa (all income levels) in 2002 to that in 2004?
Offer a very short reply. 0.81. What is the ratio of the Domestic credit (% of GDP) of Lesotho in 2002 to that in 2004?
Make the answer very short. 2.34. What is the ratio of the Domestic credit (% of GDP) in Russian Federation in 2002 to that in 2004?
Your answer should be very brief. 0.74. What is the ratio of the Domestic credit (% of GDP) in Europe(developing only) in 2002 to that in 2005?
Your response must be concise. 0.6. What is the ratio of the Domestic credit (% of GDP) in Sub-Saharan Africa (all income levels) in 2002 to that in 2005?
Ensure brevity in your answer.  0.81. What is the ratio of the Domestic credit (% of GDP) of Lesotho in 2002 to that in 2005?
Your answer should be compact. 1.68. What is the ratio of the Domestic credit (% of GDP) of Russian Federation in 2002 to that in 2005?
Your response must be concise. 0.69. What is the ratio of the Domestic credit (% of GDP) of Europe(developing only) in 2002 to that in 2006?
Your response must be concise. 0.49. What is the ratio of the Domestic credit (% of GDP) in Sub-Saharan Africa (all income levels) in 2002 to that in 2006?
Provide a succinct answer. 0.8. What is the ratio of the Domestic credit (% of GDP) in Lesotho in 2002 to that in 2006?
Keep it short and to the point. 1.61. What is the ratio of the Domestic credit (% of GDP) in Russian Federation in 2002 to that in 2006?
Your answer should be very brief. 0.58. What is the ratio of the Domestic credit (% of GDP) of Europe(developing only) in 2002 to that in 2007?
Provide a short and direct response. 0.4. What is the ratio of the Domestic credit (% of GDP) of Sub-Saharan Africa (all income levels) in 2002 to that in 2007?
Your answer should be very brief. 0.72. What is the ratio of the Domestic credit (% of GDP) of Lesotho in 2002 to that in 2007?
Offer a terse response. 1.41. What is the ratio of the Domestic credit (% of GDP) of Russian Federation in 2002 to that in 2007?
Provide a succinct answer. 0.48. What is the ratio of the Domestic credit (% of GDP) of Europe(developing only) in 2002 to that in 2008?
Your response must be concise. 0.36. What is the ratio of the Domestic credit (% of GDP) in Sub-Saharan Africa (all income levels) in 2002 to that in 2008?
Keep it short and to the point. 0.75. What is the ratio of the Domestic credit (% of GDP) of Lesotho in 2002 to that in 2008?
Offer a very short reply. 1.37. What is the ratio of the Domestic credit (% of GDP) of Russian Federation in 2002 to that in 2008?
Your response must be concise. 0.43. What is the ratio of the Domestic credit (% of GDP) of Europe(developing only) in 2003 to that in 2004?
Your response must be concise. 0.86. What is the ratio of the Domestic credit (% of GDP) in Sub-Saharan Africa (all income levels) in 2003 to that in 2004?
Keep it short and to the point. 0.96. What is the ratio of the Domestic credit (% of GDP) in Lesotho in 2003 to that in 2004?
Offer a very short reply. 0.99. What is the ratio of the Domestic credit (% of GDP) in Russian Federation in 2003 to that in 2004?
Offer a very short reply. 0.87. What is the ratio of the Domestic credit (% of GDP) in Europe(developing only) in 2003 to that in 2005?
Your response must be concise. 0.68. What is the ratio of the Domestic credit (% of GDP) of Sub-Saharan Africa (all income levels) in 2003 to that in 2005?
Your answer should be compact. 0.96. What is the ratio of the Domestic credit (% of GDP) in Lesotho in 2003 to that in 2005?
Give a very brief answer. 0.71. What is the ratio of the Domestic credit (% of GDP) in Russian Federation in 2003 to that in 2005?
Give a very brief answer. 0.82. What is the ratio of the Domestic credit (% of GDP) of Europe(developing only) in 2003 to that in 2006?
Provide a succinct answer. 0.55. What is the ratio of the Domestic credit (% of GDP) of Sub-Saharan Africa (all income levels) in 2003 to that in 2006?
Keep it short and to the point. 0.95. What is the ratio of the Domestic credit (% of GDP) of Lesotho in 2003 to that in 2006?
Make the answer very short. 0.68. What is the ratio of the Domestic credit (% of GDP) of Russian Federation in 2003 to that in 2006?
Give a very brief answer. 0.69. What is the ratio of the Domestic credit (% of GDP) in Europe(developing only) in 2003 to that in 2007?
Offer a terse response. 0.45. What is the ratio of the Domestic credit (% of GDP) of Sub-Saharan Africa (all income levels) in 2003 to that in 2007?
Ensure brevity in your answer.  0.86. What is the ratio of the Domestic credit (% of GDP) of Lesotho in 2003 to that in 2007?
Your answer should be compact. 0.6. What is the ratio of the Domestic credit (% of GDP) in Russian Federation in 2003 to that in 2007?
Your response must be concise. 0.56. What is the ratio of the Domestic credit (% of GDP) in Europe(developing only) in 2003 to that in 2008?
Make the answer very short. 0.41. What is the ratio of the Domestic credit (% of GDP) in Sub-Saharan Africa (all income levels) in 2003 to that in 2008?
Keep it short and to the point. 0.89. What is the ratio of the Domestic credit (% of GDP) in Lesotho in 2003 to that in 2008?
Offer a terse response. 0.58. What is the ratio of the Domestic credit (% of GDP) in Russian Federation in 2003 to that in 2008?
Your answer should be compact. 0.51. What is the ratio of the Domestic credit (% of GDP) in Europe(developing only) in 2004 to that in 2005?
Provide a succinct answer. 0.79. What is the ratio of the Domestic credit (% of GDP) of Sub-Saharan Africa (all income levels) in 2004 to that in 2005?
Offer a terse response. 1. What is the ratio of the Domestic credit (% of GDP) of Lesotho in 2004 to that in 2005?
Offer a terse response. 0.72. What is the ratio of the Domestic credit (% of GDP) in Russian Federation in 2004 to that in 2005?
Provide a short and direct response. 0.94. What is the ratio of the Domestic credit (% of GDP) of Europe(developing only) in 2004 to that in 2006?
Make the answer very short. 0.64. What is the ratio of the Domestic credit (% of GDP) in Sub-Saharan Africa (all income levels) in 2004 to that in 2006?
Give a very brief answer. 0.98. What is the ratio of the Domestic credit (% of GDP) of Lesotho in 2004 to that in 2006?
Your response must be concise. 0.69. What is the ratio of the Domestic credit (% of GDP) in Russian Federation in 2004 to that in 2006?
Make the answer very short. 0.79. What is the ratio of the Domestic credit (% of GDP) in Europe(developing only) in 2004 to that in 2007?
Ensure brevity in your answer.  0.52. What is the ratio of the Domestic credit (% of GDP) in Sub-Saharan Africa (all income levels) in 2004 to that in 2007?
Give a very brief answer. 0.9. What is the ratio of the Domestic credit (% of GDP) of Lesotho in 2004 to that in 2007?
Provide a succinct answer. 0.6. What is the ratio of the Domestic credit (% of GDP) of Russian Federation in 2004 to that in 2007?
Your answer should be compact. 0.64. What is the ratio of the Domestic credit (% of GDP) in Europe(developing only) in 2004 to that in 2008?
Provide a short and direct response. 0.47. What is the ratio of the Domestic credit (% of GDP) in Sub-Saharan Africa (all income levels) in 2004 to that in 2008?
Give a very brief answer. 0.93. What is the ratio of the Domestic credit (% of GDP) in Lesotho in 2004 to that in 2008?
Make the answer very short. 0.58. What is the ratio of the Domestic credit (% of GDP) in Russian Federation in 2004 to that in 2008?
Offer a very short reply. 0.59. What is the ratio of the Domestic credit (% of GDP) of Europe(developing only) in 2005 to that in 2006?
Offer a very short reply. 0.81. What is the ratio of the Domestic credit (% of GDP) in Sub-Saharan Africa (all income levels) in 2005 to that in 2006?
Provide a succinct answer. 0.98. What is the ratio of the Domestic credit (% of GDP) in Lesotho in 2005 to that in 2006?
Provide a succinct answer. 0.96. What is the ratio of the Domestic credit (% of GDP) in Russian Federation in 2005 to that in 2006?
Keep it short and to the point. 0.84. What is the ratio of the Domestic credit (% of GDP) of Europe(developing only) in 2005 to that in 2007?
Your answer should be very brief. 0.66. What is the ratio of the Domestic credit (% of GDP) of Sub-Saharan Africa (all income levels) in 2005 to that in 2007?
Ensure brevity in your answer.  0.89. What is the ratio of the Domestic credit (% of GDP) of Lesotho in 2005 to that in 2007?
Give a very brief answer. 0.84. What is the ratio of the Domestic credit (% of GDP) in Russian Federation in 2005 to that in 2007?
Make the answer very short. 0.69. What is the ratio of the Domestic credit (% of GDP) in Europe(developing only) in 2005 to that in 2008?
Keep it short and to the point. 0.6. What is the ratio of the Domestic credit (% of GDP) in Sub-Saharan Africa (all income levels) in 2005 to that in 2008?
Make the answer very short. 0.93. What is the ratio of the Domestic credit (% of GDP) in Lesotho in 2005 to that in 2008?
Your response must be concise. 0.81. What is the ratio of the Domestic credit (% of GDP) in Russian Federation in 2005 to that in 2008?
Provide a succinct answer. 0.62. What is the ratio of the Domestic credit (% of GDP) of Europe(developing only) in 2006 to that in 2007?
Ensure brevity in your answer.  0.82. What is the ratio of the Domestic credit (% of GDP) in Sub-Saharan Africa (all income levels) in 2006 to that in 2007?
Keep it short and to the point. 0.91. What is the ratio of the Domestic credit (% of GDP) in Lesotho in 2006 to that in 2007?
Ensure brevity in your answer.  0.88. What is the ratio of the Domestic credit (% of GDP) in Russian Federation in 2006 to that in 2007?
Your response must be concise. 0.82. What is the ratio of the Domestic credit (% of GDP) of Europe(developing only) in 2006 to that in 2008?
Your answer should be compact. 0.74. What is the ratio of the Domestic credit (% of GDP) of Sub-Saharan Africa (all income levels) in 2006 to that in 2008?
Your answer should be very brief. 0.94. What is the ratio of the Domestic credit (% of GDP) in Lesotho in 2006 to that in 2008?
Offer a terse response. 0.85. What is the ratio of the Domestic credit (% of GDP) in Russian Federation in 2006 to that in 2008?
Offer a terse response. 0.74. What is the ratio of the Domestic credit (% of GDP) of Europe(developing only) in 2007 to that in 2008?
Your answer should be very brief. 0.9. What is the ratio of the Domestic credit (% of GDP) of Sub-Saharan Africa (all income levels) in 2007 to that in 2008?
Keep it short and to the point. 1.03. What is the ratio of the Domestic credit (% of GDP) of Lesotho in 2007 to that in 2008?
Your response must be concise. 0.97. What is the ratio of the Domestic credit (% of GDP) in Russian Federation in 2007 to that in 2008?
Your answer should be very brief. 0.91. What is the difference between the highest and the second highest Domestic credit (% of GDP) of Europe(developing only)?
Give a very brief answer. 3.93. What is the difference between the highest and the second highest Domestic credit (% of GDP) in Sub-Saharan Africa (all income levels)?
Offer a terse response. 1.32. What is the difference between the highest and the second highest Domestic credit (% of GDP) in Lesotho?
Your answer should be compact. 3.9. What is the difference between the highest and the second highest Domestic credit (% of GDP) in Russian Federation?
Your answer should be compact. 3.77. What is the difference between the highest and the lowest Domestic credit (% of GDP) of Europe(developing only)?
Ensure brevity in your answer.  25.75. What is the difference between the highest and the lowest Domestic credit (% of GDP) of Sub-Saharan Africa (all income levels)?
Provide a short and direct response. 11.02. What is the difference between the highest and the lowest Domestic credit (% of GDP) of Lesotho?
Make the answer very short. 8.38. What is the difference between the highest and the lowest Domestic credit (% of GDP) in Russian Federation?
Ensure brevity in your answer.  23.57. 